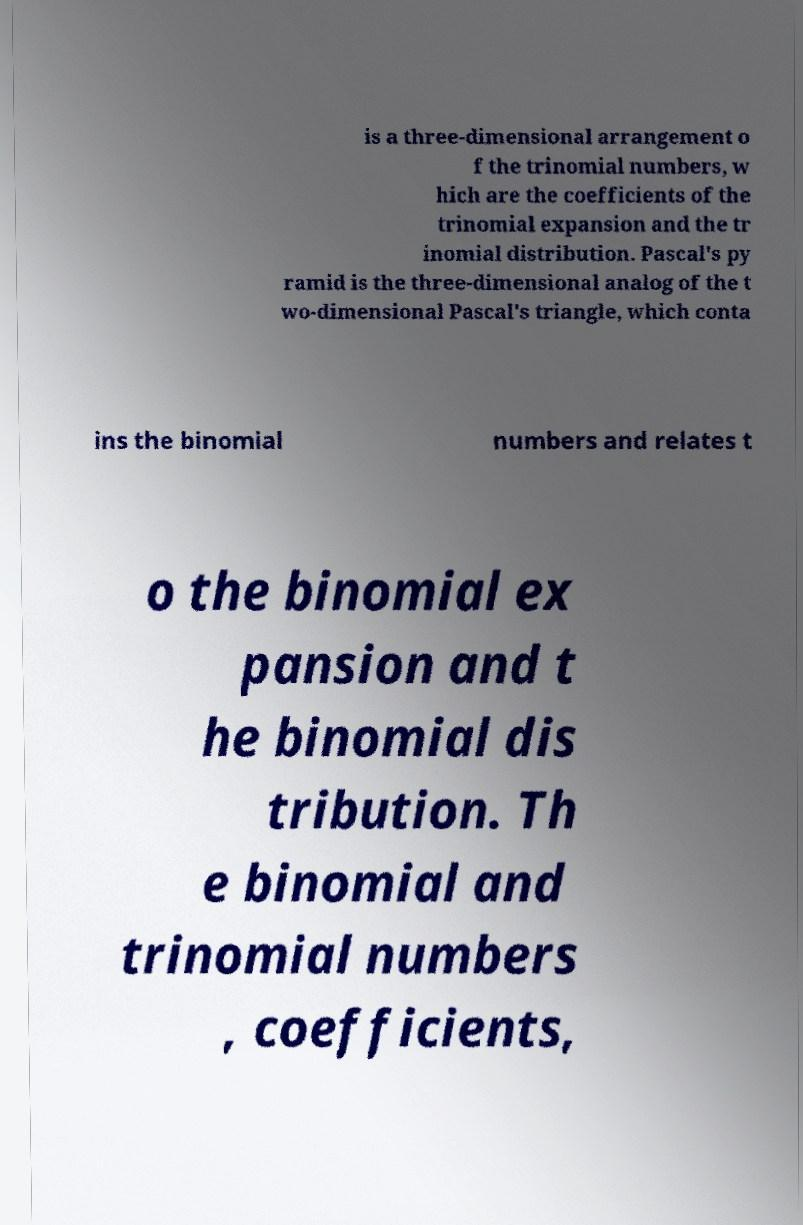I need the written content from this picture converted into text. Can you do that? is a three-dimensional arrangement o f the trinomial numbers, w hich are the coefficients of the trinomial expansion and the tr inomial distribution. Pascal's py ramid is the three-dimensional analog of the t wo-dimensional Pascal's triangle, which conta ins the binomial numbers and relates t o the binomial ex pansion and t he binomial dis tribution. Th e binomial and trinomial numbers , coefficients, 